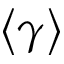Convert formula to latex. <formula><loc_0><loc_0><loc_500><loc_500>\left < \gamma \right ></formula> 